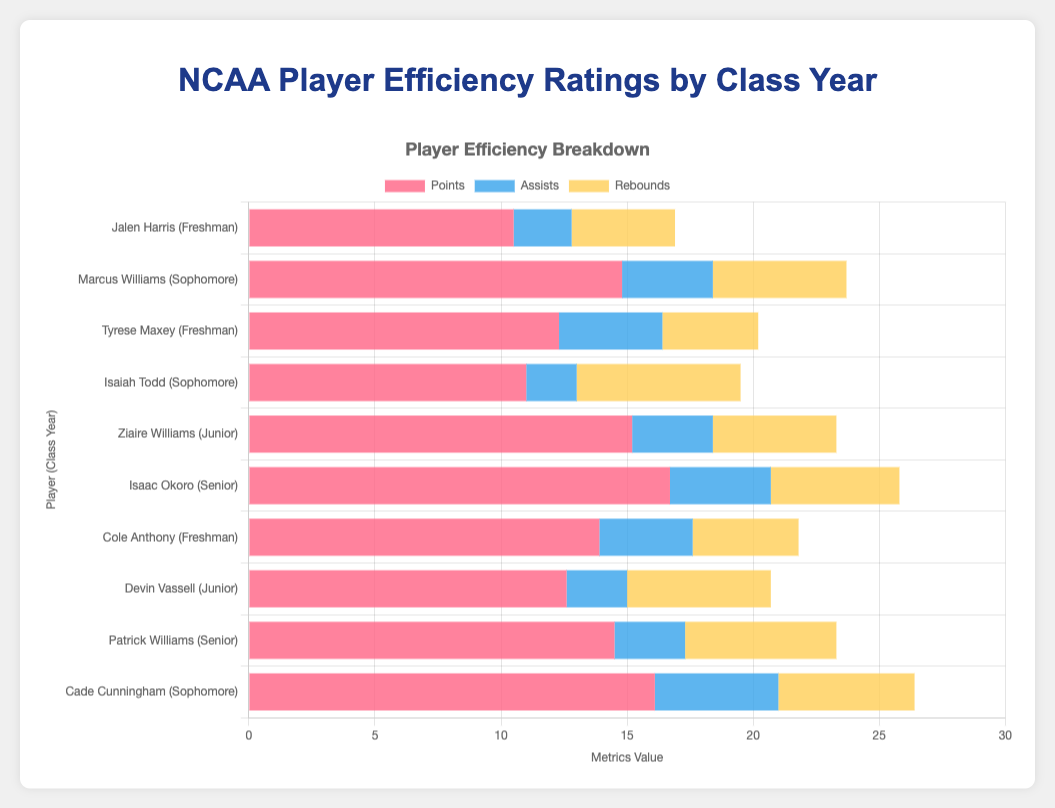Which player had the highest overall player efficiency rating? Look at the tooltip that displays the player efficiency rating when hovering over each bar. The highest value in this case is "Cade Cunningham" with a rating of "21.2".
Answer: Cade Cunningham Compare the points scored by the two freshmen with the highest player efficiency ratings. Who scored more? Identify the freshmen with the highest player efficiency ratings, which are "Tyrese Maxey" (16.2) and "Cole Anthony" (18.3). Then compare their points: Tyrese Maxey (12.3 points) and Cole Anthony (13.9 points).
Answer: Cole Anthony Which class year had the player with the lowest player efficiency rating, and what is that rating? Look at the player efficiency rating values in the tooltips for all players. The lowest rating is from "Jalen Harris" (15.3), who is a freshman.
Answer: Freshman, 15.3 Sum the assists and rebounds for Ziaire Williams. What is the total? Locate Ziaire Williams in the dataset and sum his assists (3.2) and rebounds (4.9). 3.2 + 4.9 = 8.1
Answer: 8.1 Which player has more rebounds, Devin Vassell or Marcus Williams? Compare the rebound values for Devin Vassell (5.7) and Marcus Williams (5.3) as shown in their respective bars.
Answer: Devin Vassell Which metric is the primary contributor to Patrick Williams' player efficiency rating? Look at the length of the bars for points, assists, and rebounds for Patrick Williams. Points (14.5) is the longest bar.
Answer: Points Who scored more points, Marcus Williams or Isaac Okoro? Compare the points values for Marcus Williams (14.8) and Isaac Okoro (16.7).
Answer: Isaac Okoro How do the assists of freshmen compare to those of sophomores? Sum up the assists for the freshmen (2.3 + 4.1 + 3.7) and sophomores (3.6 + 2.0 + 4.9). Freshmen: 2.3 + 4.1 + 3.7 = 10.1; Sophomores: 3.6 + 2.0 + 4.9 = 10.5
Answer: Freshmen = 10.1, Sophomores = 10.5 What is the average player efficiency rating for seniors? List the player efficiency ratings for seniors (20.5 and 19.4). Calculate the average: (20.5 + 19.4) / 2 = 19.95
Answer: 19.95 Who has higher total metrics (points + assists + rebounds) between Tyrese Maxey and Jalen Harris? Sum metrics for both players: Tyrese Maxey (12.3 + 4.1 + 3.8 = 20.2) and Jalen Harris (10.5 + 2.3 + 4.1 = 16.9). 20.2 is higher than 16.9.
Answer: Tyrese Maxey 